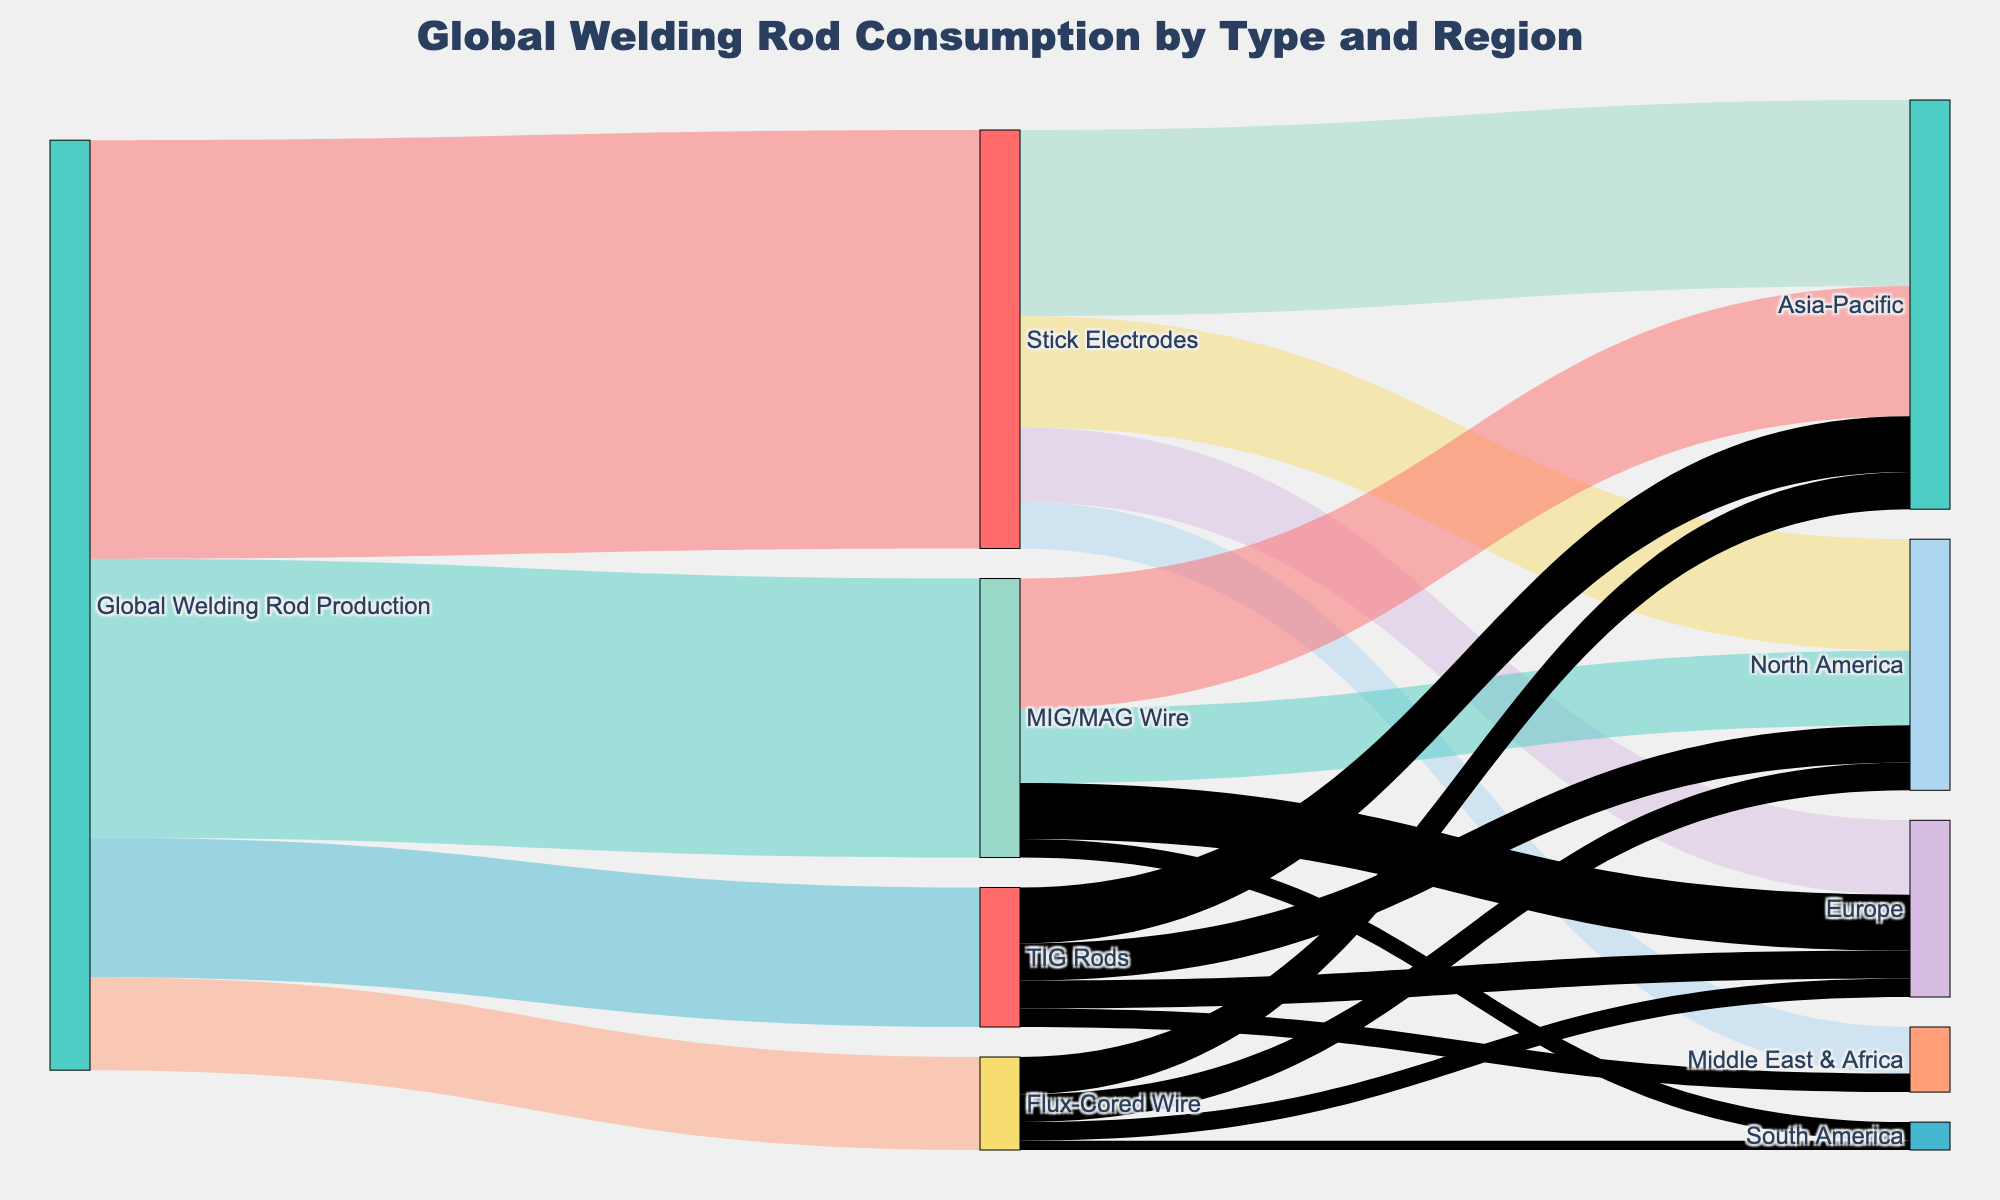What is the total global welding rod production value represented in the diagram? The diagram shows the following values for global welding rod production: Stick Electrodes (45), MIG/MAG Wire (30), TIG Rods (15), and Flux-Cored Wire (10). Summing these values gives 45 + 30 + 15 + 10 = 100.
Answer: 100 Which type of welding rod has the highest consumption in the Asia-Pacific region? According to the diagram, the consumption values for the Asia-Pacific region are: Stick Electrodes (20), MIG/MAG Wire (14), TIG Rods (6), and Flux-Cored Wire (4). Here, Stick Electrodes have the highest value of 20.
Answer: Stick Electrodes How many regions consume Stick Electrodes based on the diagram? The diagram shows Stick Electrodes being consumed in Asia-Pacific (20), North America (12), Europe (8), and Middle East & Africa (5). The total number of regions is 4.
Answer: 4 What is the difference in consumption between Stick Electrodes in North America and Europe? The consumption values for Stick Electrodes in North America and Europe are 12 and 8 respectively. The difference is 12 - 8 = 4.
Answer: 4 Which region has the lowest total welding rod consumption, and what is the value? Summing up the welding rod consumptions for each region:
- Asia-Pacific: 20 (Stick Electrodes) + 14 (MIG/MAG Wire) + 6 (TIG Rods) + 4 (Flux-Cored Wire) = 44
- North America: 12 (Stick Electrodes) + 8 (MIG/MAG Wire) + 4 (TIG Rods) + 3 (Flux-Cored Wire) = 27
- Europe: 8 (Stick Electrodes) + 6 (MIG/MAG Wire) + 3 (TIG Rods) + 2 (Flux-Cored Wire) = 19
- Middle East & Africa: 5 (Stick Electrodes) + 2 (TIG Rods) = 7
- South America: 2 (MIG/MAG Wire) + 1 (Flux-Cored Wire) = 3
The region with the lowest total is South America with 3.
Answer: South America, 3 Which type of welding rod is consumed the least globally, and what is the value? Summing up the global consumption of each type:
- Stick Electrodes: 20 (Asia-Pacific) + 12 (North America) + 8 (Europe) + 5 (Middle East & Africa) = 45
- MIG/MAG Wire: 14 (Asia-Pacific) + 8 (North America) + 6 (Europe) + 2 (South America) = 30
- TIG Rods: 6 (Asia-Pacific) + 4 (North America) + 3 (Europe) + 2 (Middle East & Africa) = 15
- Flux-Cored Wire: 4 (Asia-Pacific) + 3 (North America) + 2 (Europe) + 1 (South America) = 10
Flux-Cored Wire is consumed the least globally with a value of 10.
Answer: Flux-Cored Wire, 10 How does the consumption of MIG/MAG Wire in Europe compare to that in North America? The consumption of MIG/MAG Wire in Europe is 6, while in North America it is 8. The consumption in Europe is lower than in North America.
Answer: Lower What is the total number of distinct nodes (types and regions) in the Sankey diagram? The distinct nodes in the diagram include: Global Welding Rod Production, Stick Electrodes, MIG/MAG Wire, TIG Rods, Flux-Cored Wire, Asia-Pacific, North America, Europe, Middle East & Africa, and South America. Counting these gives a total of 10 distinct nodes.
Answer: 10 